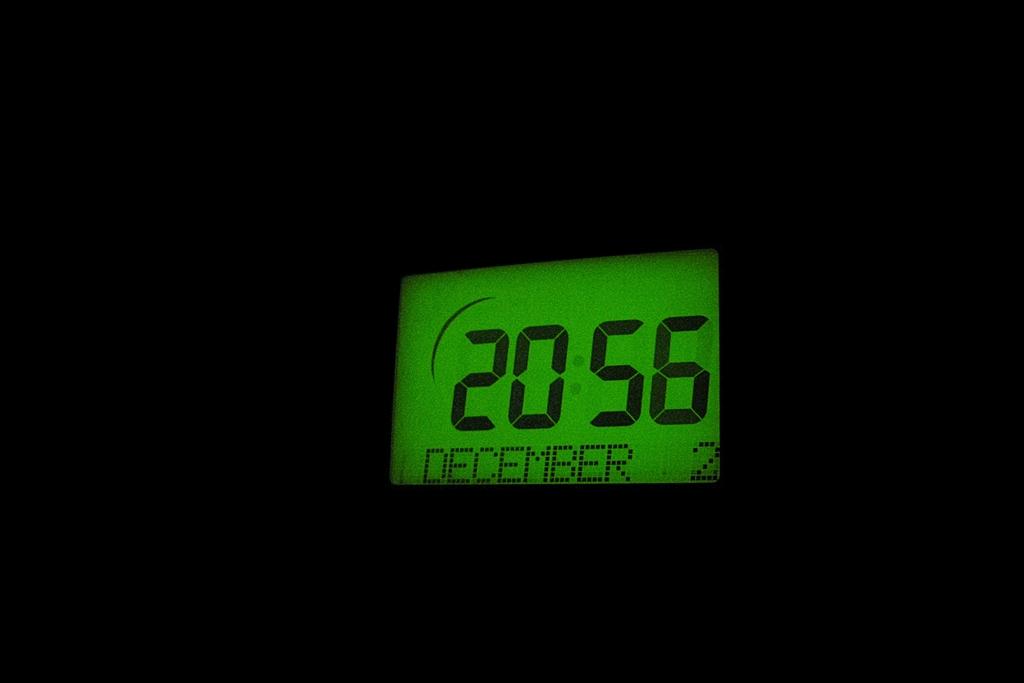What time is it?
Give a very brief answer. 20:56. What month is displayed on screen?
Your answer should be very brief. December. 